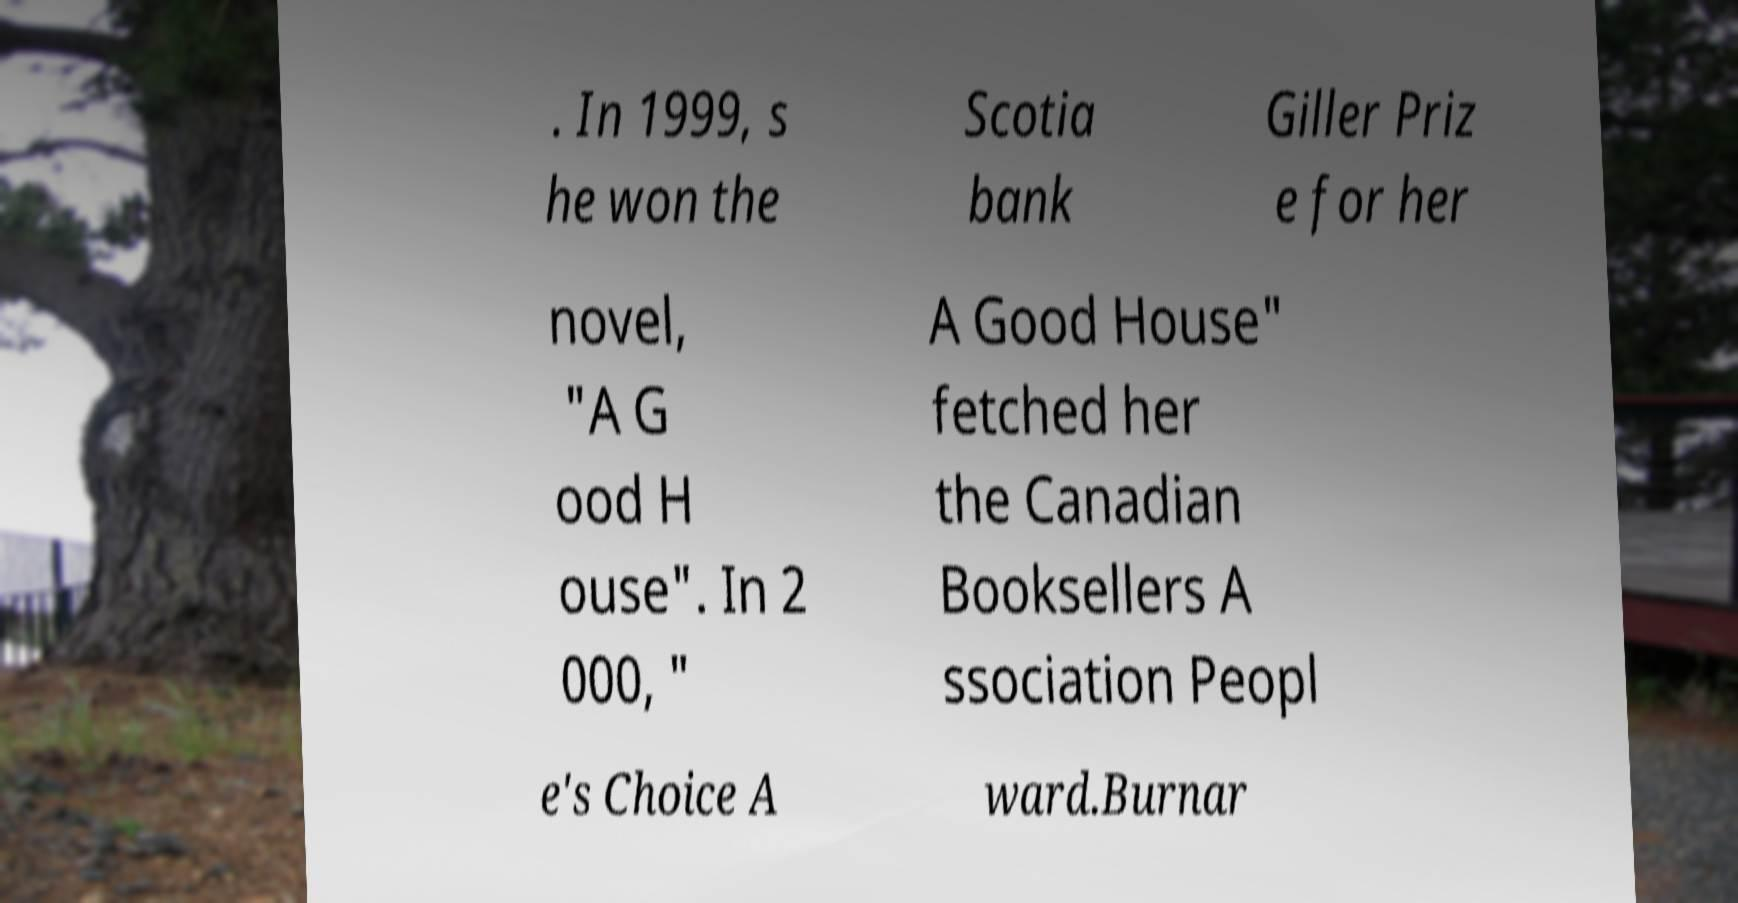Can you read and provide the text displayed in the image?This photo seems to have some interesting text. Can you extract and type it out for me? . In 1999, s he won the Scotia bank Giller Priz e for her novel, "A G ood H ouse". In 2 000, " A Good House" fetched her the Canadian Booksellers A ssociation Peopl e's Choice A ward.Burnar 